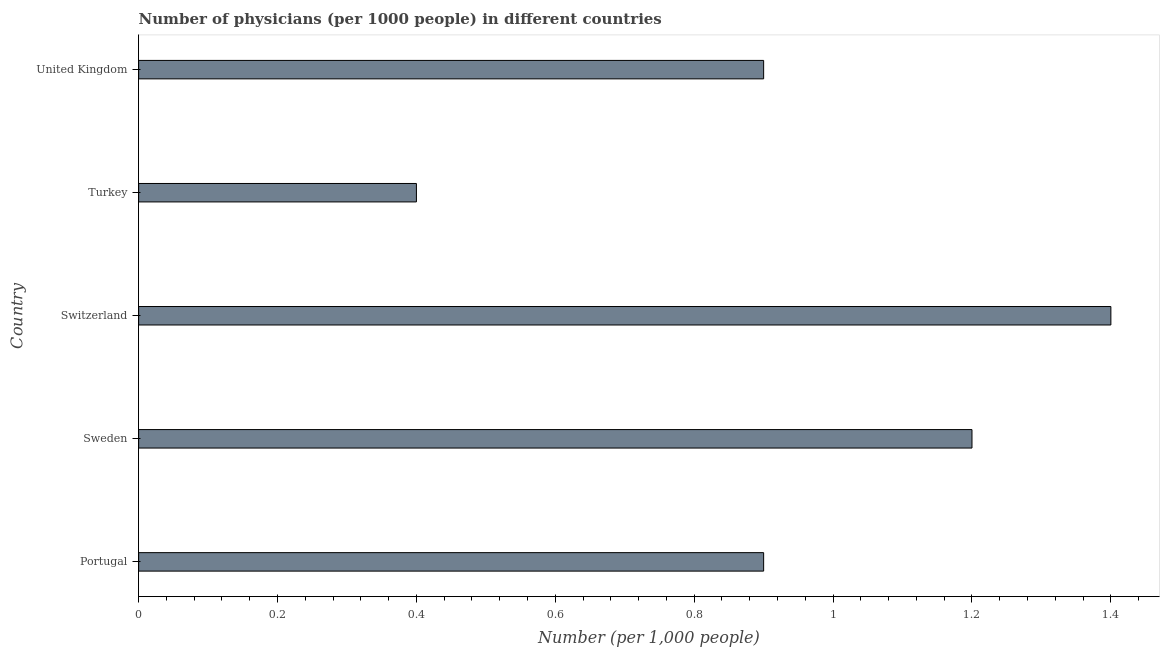Does the graph contain any zero values?
Your response must be concise. No. Does the graph contain grids?
Your response must be concise. No. What is the title of the graph?
Give a very brief answer. Number of physicians (per 1000 people) in different countries. What is the label or title of the X-axis?
Offer a terse response. Number (per 1,0 people). Across all countries, what is the minimum number of physicians?
Give a very brief answer. 0.4. In which country was the number of physicians maximum?
Offer a very short reply. Switzerland. In which country was the number of physicians minimum?
Keep it short and to the point. Turkey. What is the sum of the number of physicians?
Keep it short and to the point. 4.8. What is the median number of physicians?
Your response must be concise. 0.9. In how many countries, is the number of physicians greater than 0.76 ?
Keep it short and to the point. 4. What is the ratio of the number of physicians in Turkey to that in United Kingdom?
Ensure brevity in your answer.  0.44. Is the number of physicians in Portugal less than that in Switzerland?
Your answer should be very brief. Yes. Is the difference between the number of physicians in Portugal and United Kingdom greater than the difference between any two countries?
Your response must be concise. No. What is the difference between the highest and the lowest number of physicians?
Provide a succinct answer. 1. How many bars are there?
Your answer should be compact. 5. Are all the bars in the graph horizontal?
Ensure brevity in your answer.  Yes. Are the values on the major ticks of X-axis written in scientific E-notation?
Offer a very short reply. No. What is the Number (per 1,000 people) of Switzerland?
Provide a short and direct response. 1.4. What is the Number (per 1,000 people) in Turkey?
Your response must be concise. 0.4. What is the difference between the Number (per 1,000 people) in Portugal and Sweden?
Keep it short and to the point. -0.3. What is the difference between the Number (per 1,000 people) in Portugal and Switzerland?
Offer a very short reply. -0.5. What is the difference between the Number (per 1,000 people) in Switzerland and Turkey?
Your answer should be very brief. 1. What is the difference between the Number (per 1,000 people) in Switzerland and United Kingdom?
Your answer should be very brief. 0.5. What is the ratio of the Number (per 1,000 people) in Portugal to that in Sweden?
Your answer should be very brief. 0.75. What is the ratio of the Number (per 1,000 people) in Portugal to that in Switzerland?
Give a very brief answer. 0.64. What is the ratio of the Number (per 1,000 people) in Portugal to that in Turkey?
Provide a succinct answer. 2.25. What is the ratio of the Number (per 1,000 people) in Sweden to that in Switzerland?
Ensure brevity in your answer.  0.86. What is the ratio of the Number (per 1,000 people) in Sweden to that in United Kingdom?
Your answer should be compact. 1.33. What is the ratio of the Number (per 1,000 people) in Switzerland to that in Turkey?
Provide a succinct answer. 3.5. What is the ratio of the Number (per 1,000 people) in Switzerland to that in United Kingdom?
Provide a short and direct response. 1.56. What is the ratio of the Number (per 1,000 people) in Turkey to that in United Kingdom?
Your answer should be compact. 0.44. 